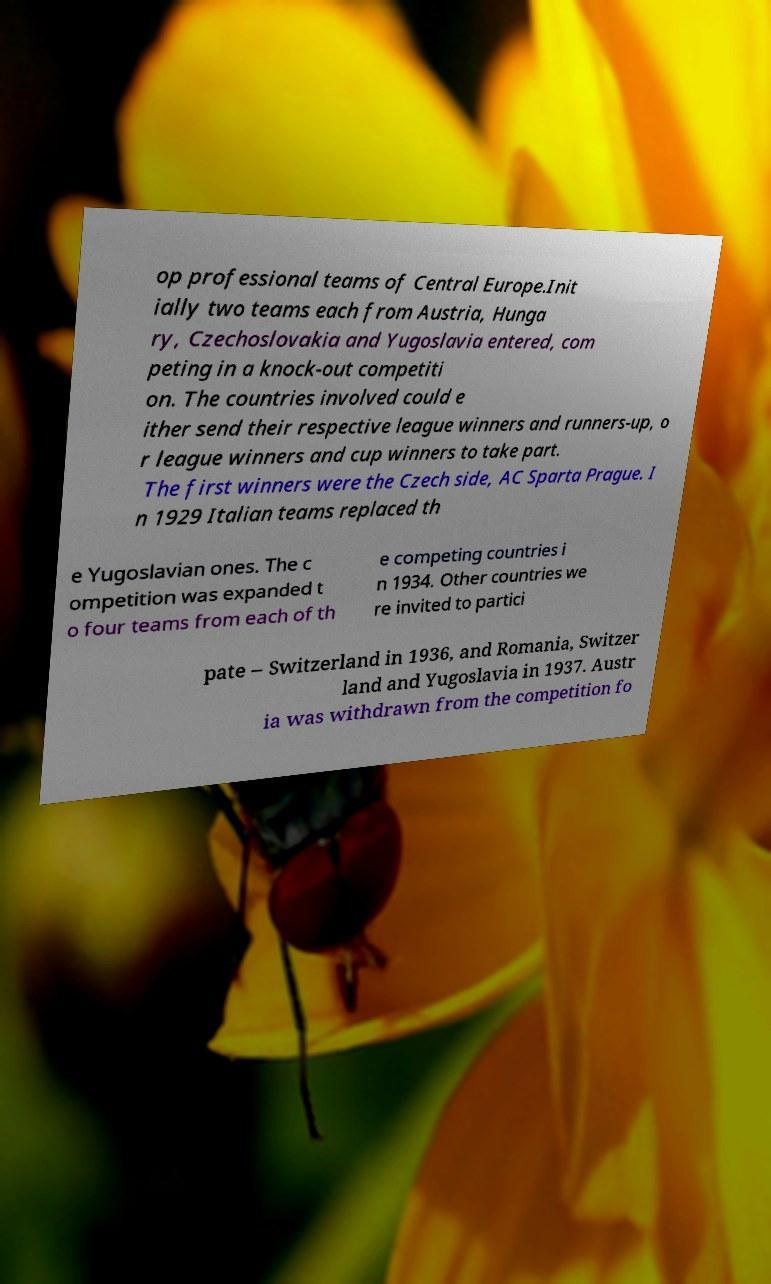There's text embedded in this image that I need extracted. Can you transcribe it verbatim? op professional teams of Central Europe.Init ially two teams each from Austria, Hunga ry, Czechoslovakia and Yugoslavia entered, com peting in a knock-out competiti on. The countries involved could e ither send their respective league winners and runners-up, o r league winners and cup winners to take part. The first winners were the Czech side, AC Sparta Prague. I n 1929 Italian teams replaced th e Yugoslavian ones. The c ompetition was expanded t o four teams from each of th e competing countries i n 1934. Other countries we re invited to partici pate – Switzerland in 1936, and Romania, Switzer land and Yugoslavia in 1937. Austr ia was withdrawn from the competition fo 